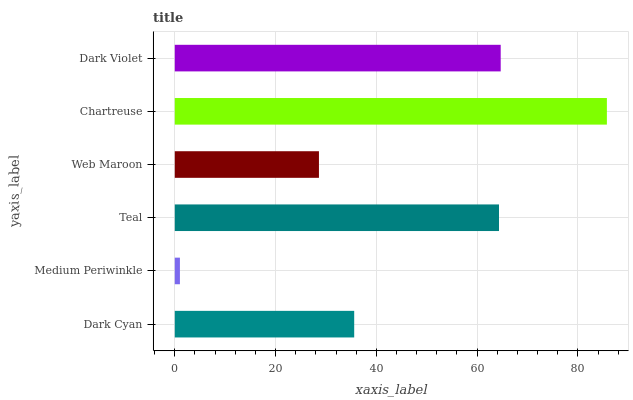Is Medium Periwinkle the minimum?
Answer yes or no. Yes. Is Chartreuse the maximum?
Answer yes or no. Yes. Is Teal the minimum?
Answer yes or no. No. Is Teal the maximum?
Answer yes or no. No. Is Teal greater than Medium Periwinkle?
Answer yes or no. Yes. Is Medium Periwinkle less than Teal?
Answer yes or no. Yes. Is Medium Periwinkle greater than Teal?
Answer yes or no. No. Is Teal less than Medium Periwinkle?
Answer yes or no. No. Is Teal the high median?
Answer yes or no. Yes. Is Dark Cyan the low median?
Answer yes or no. Yes. Is Medium Periwinkle the high median?
Answer yes or no. No. Is Chartreuse the low median?
Answer yes or no. No. 